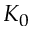<formula> <loc_0><loc_0><loc_500><loc_500>K _ { 0 }</formula> 